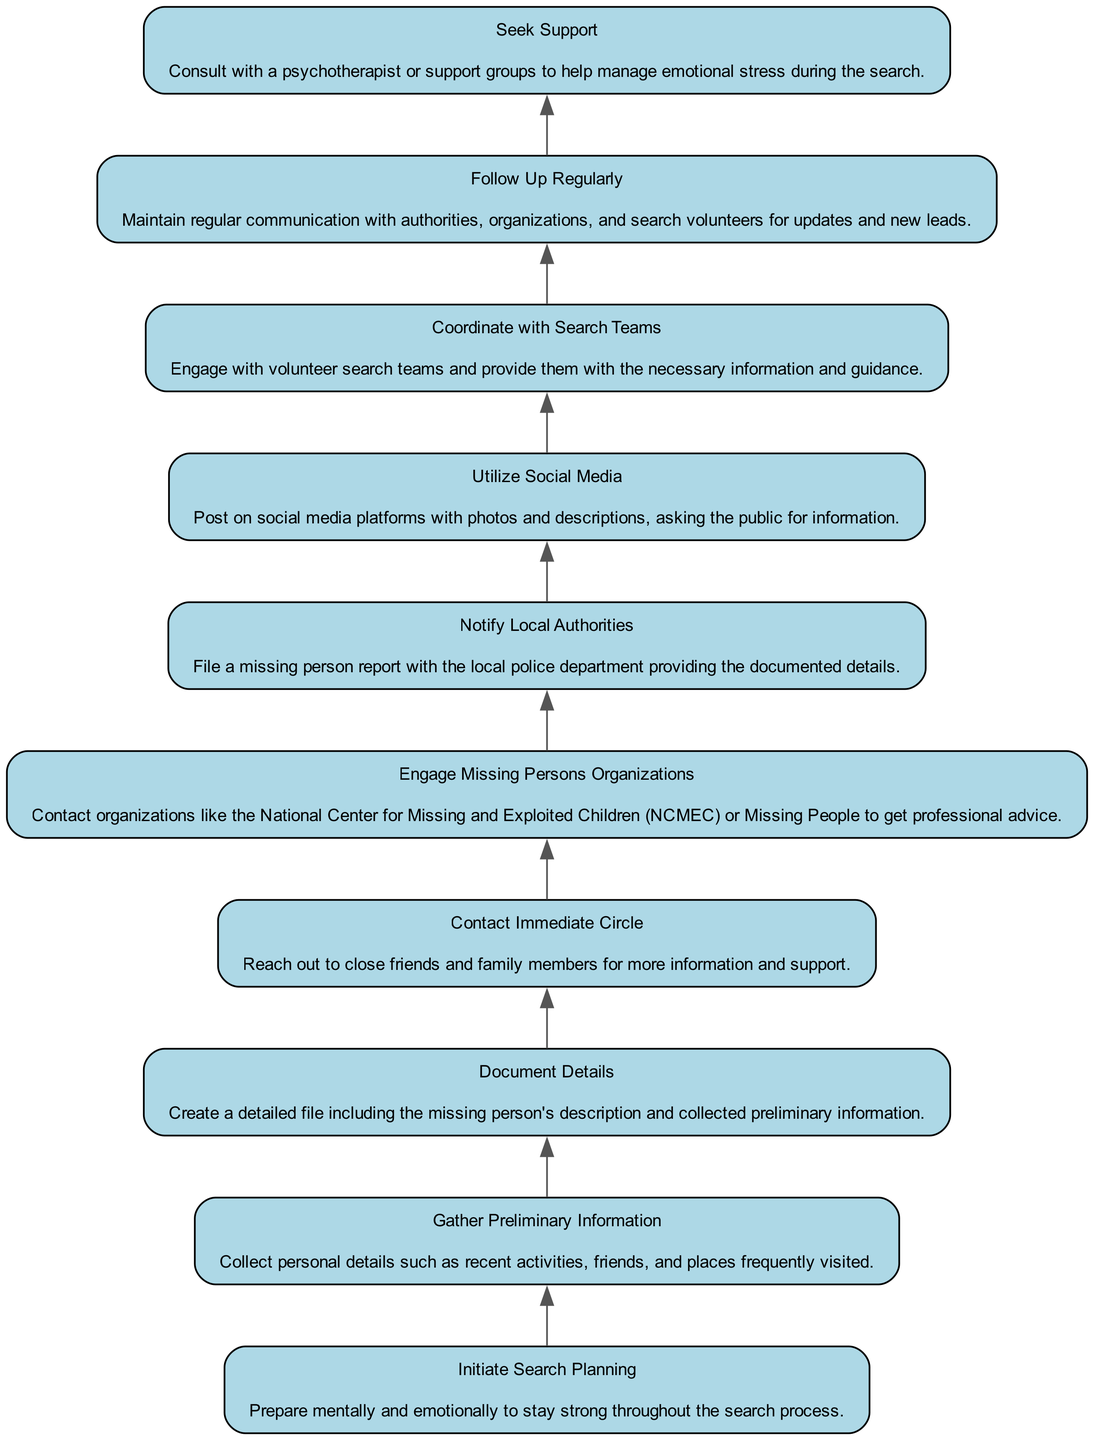What is the first step in the search planning? The diagram lists "Initiate Search Planning" as the first step, which prepares the individual mentally and emotionally for the search process.
Answer: Initiate Search Planning How many steps are there in the process? By counting the nodes in the diagram, there are a total of 10 steps in the search planning process from initiating the plan to following up regularly.
Answer: 10 Which step comes after "Gather Preliminary Information"? According to the diagram, the step that follows "Gather Preliminary Information" is "Document Details." This indicates a flow from gathering information to documenting it as part of the planning.
Answer: Document Details What action is associated with "Contact Immediate Circle"? The action associated with "Contact Immediate Circle" is to reach out to close friends and family members for more information and support.
Answer: Reach out to close friends and family members for more information and support Which step involves engaging with professional organizations? The diagram indicates that "Engage Missing Persons Organizations" is the step that involves contacting organizations for professional advice during the search process.
Answer: Engage Missing Persons Organizations What is the purpose of "Notify Local Authorities"? The purpose of "Notify Local Authorities" is to file a missing person report with the local police department, providing documented details gathered earlier.
Answer: File a missing person report with the local police department What is the last step in the search process? The last step, as per the flowchart, is "Follow Up Regularly," which emphasizes the importance of communication with authorities and volunteers for updates.
Answer: Follow Up Regularly How are "Utilize Social Media" and "Coordinate with Search Teams" related in the process? In the flowchart, "Utilize Social Media" occurs before "Coordinate with Search Teams," indicating that social media outreach can help gather initial information that is then shared with search teams.
Answer: Utilize Social Media before Coordinate with Search Teams What is a recommended coping strategy during the search? The flowchart suggests "Seek Support," advising individuals to consult with a psychotherapist or support groups to manage emotional stress effectively.
Answer: Seek Support 